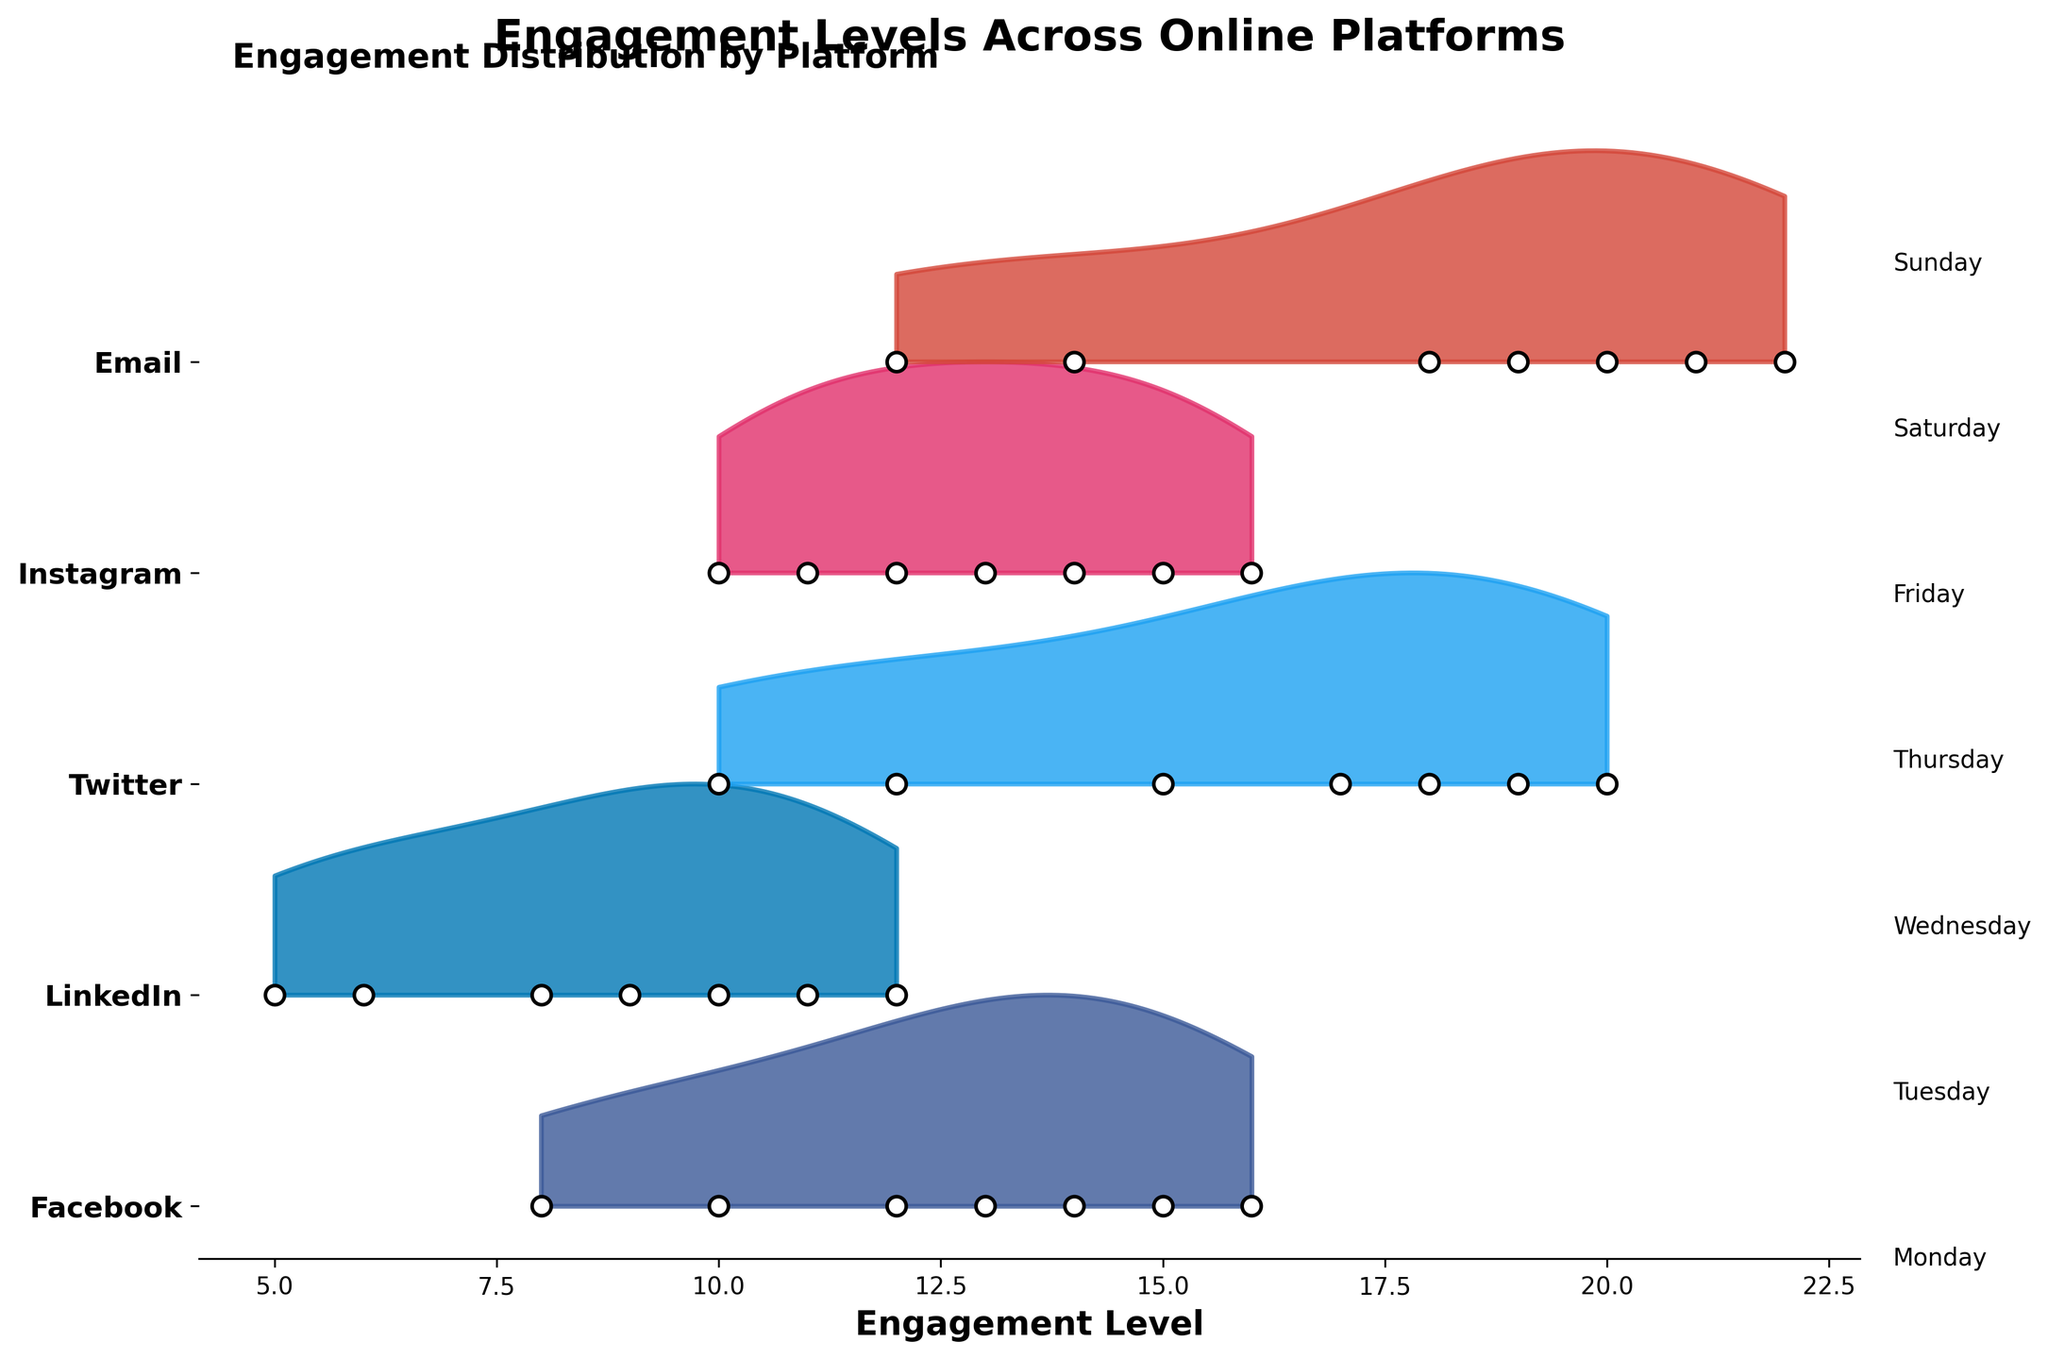what's the title of the figure? The title of the figure is displayed at the top center and is usually the largest and boldest text within the figure.
Answer: Engagement Levels Across Online Platforms what color represents Instagram in the plot? The color representing Instagram is observed from the filled area corresponding to the Instagram label on the y-axis.
Answer: Pink On which day does LinkedIn have the lowest engagement level? Observe the y-location of the filled area and the corresponding days for LinkedIn. The lowest point for LinkedIn is highlighted on that day.
Answer: Sunday Which platform shows a peak engagement level on Wednesday? Look at the peaks of each platform's filled area for Wednesday. The highest peak in the filled region shows the platform with peak engagement.
Answer: Email Calculate the average engagement level for Facebook across all days. Sum the engagement levels for Facebook across all days and divide by the number of days: (12 + 14 + 16 + 15 + 13 + 10 + 8) / 7 = 88 / 7 = 12.57.
Answer: 12.57 Compare the engagement levels of Twitter on Thursday and Sunday. Which day has higher engagement? Check the y-location of the filled area corresponding to Twitter for Thursday and Sunday and compare these values.
Answer: Thursday What is the maximum engagement level recorded across all platforms and days? Find the highest point on the x-axis across all the filled regions in the plot.
Answer: 22 Identify two platforms that have a decline in engagement from Wednesday to Thursday. Check the y-positions of the engagement levels for each platform from Wednesday to Thursday. Identify two platforms showing a decrease.
Answer: Facebook, LinkedIn Which platform has the smallest change in engagement levels throughout the week? Observe the range of engagement levels for each platform and identify which platform has the smallest spread.
Answer: Facebook 